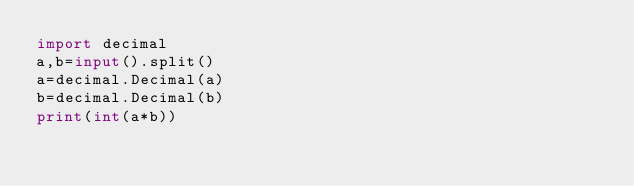<code> <loc_0><loc_0><loc_500><loc_500><_Python_>import decimal
a,b=input().split()
a=decimal.Decimal(a)
b=decimal.Decimal(b)
print(int(a*b))</code> 